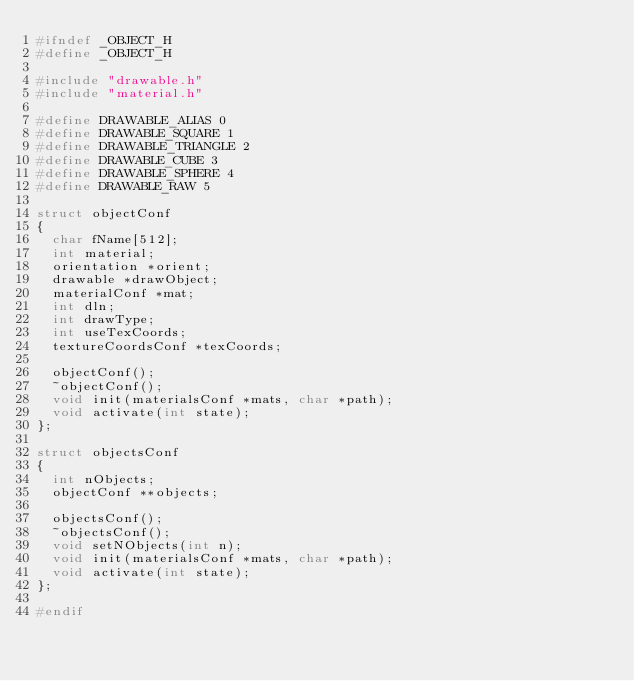Convert code to text. <code><loc_0><loc_0><loc_500><loc_500><_C_>#ifndef _OBJECT_H
#define _OBJECT_H

#include "drawable.h"
#include "material.h"

#define DRAWABLE_ALIAS 0
#define DRAWABLE_SQUARE 1
#define DRAWABLE_TRIANGLE 2
#define DRAWABLE_CUBE 3
#define DRAWABLE_SPHERE 4
#define DRAWABLE_RAW 5

struct objectConf
{
	char fName[512];
	int material;
	orientation *orient;	
	drawable *drawObject;
	materialConf *mat;
	int dln;
	int drawType;
	int useTexCoords;
	textureCoordsConf *texCoords;

	objectConf();
	~objectConf();
	void init(materialsConf *mats, char *path);
	void activate(int state);
};

struct objectsConf
{
	int nObjects;
	objectConf **objects;

	objectsConf();
	~objectsConf();
	void setNObjects(int n);
	void init(materialsConf *mats, char *path);
	void activate(int state);
};

#endif
</code> 